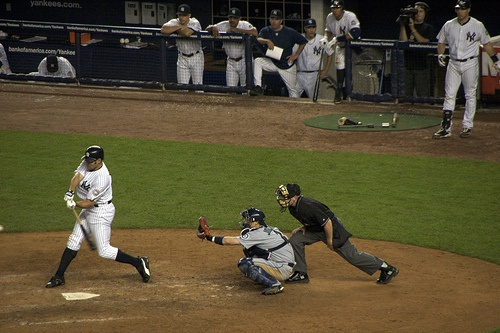Describe the objects in this image and their specific colors. I can see people in black, lightgray, darkgray, and olive tones, people in black, darkgreen, and gray tones, people in black, darkgray, and gray tones, people in black, darkgray, gray, and olive tones, and people in black, darkgray, gray, and maroon tones in this image. 